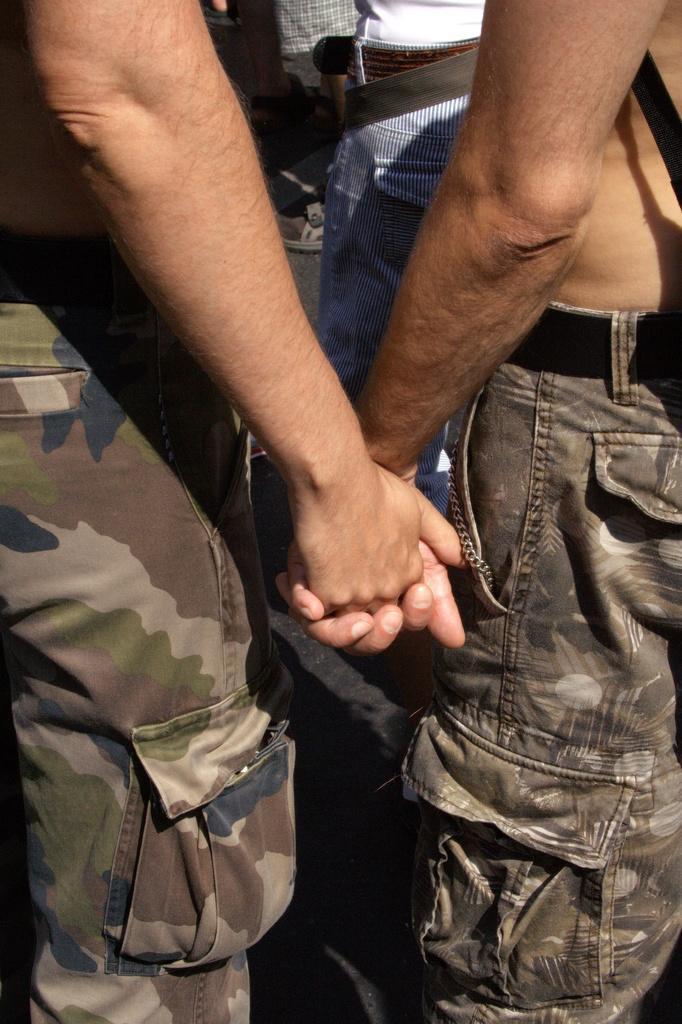How many people are in the image? There are two persons in the image. What are the two persons doing? The two persons are holding hands. Can you describe the background of the image? The background includes a road and other persons visible in the background. What type of hat is the doctor wearing in the image? There is no doctor or hat present in the image. What is the crook doing in the image? There is no crook present in the image. 